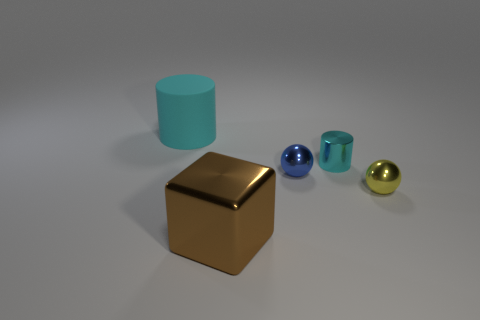What is the size of the rubber object that is the same color as the small metal cylinder?
Your answer should be very brief. Large. What number of things are cyan things that are in front of the big rubber cylinder or cyan things that are on the right side of the big cyan object?
Make the answer very short. 1. Are there any cyan matte cubes that have the same size as the blue sphere?
Provide a succinct answer. No. What is the color of the other tiny object that is the same shape as the cyan rubber thing?
Offer a terse response. Cyan. Are there any large cyan objects to the right of the cyan object right of the large matte cylinder?
Keep it short and to the point. No. There is a cyan rubber thing that is behind the metal cube; is it the same shape as the big brown metallic object?
Make the answer very short. No. The rubber thing has what shape?
Give a very brief answer. Cylinder. What number of yellow things are the same material as the small blue object?
Keep it short and to the point. 1. Is the color of the matte object the same as the big thing in front of the big matte thing?
Give a very brief answer. No. How many metallic blocks are there?
Ensure brevity in your answer.  1. 